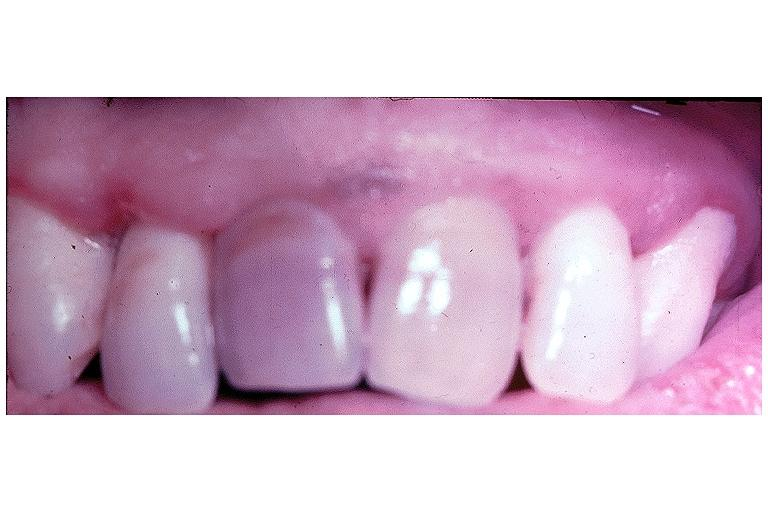s cryptosporidia present?
Answer the question using a single word or phrase. No 